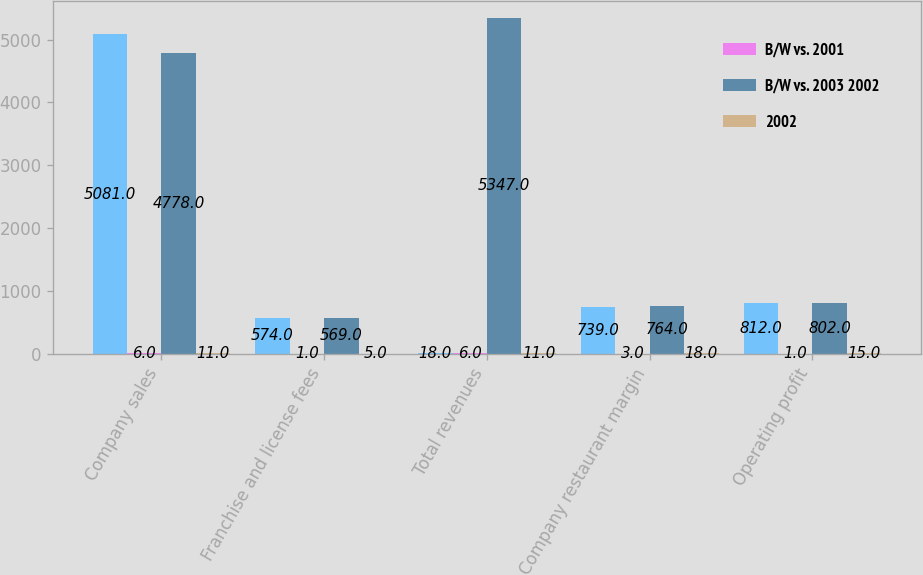<chart> <loc_0><loc_0><loc_500><loc_500><stacked_bar_chart><ecel><fcel>Company sales<fcel>Franchise and license fees<fcel>Total revenues<fcel>Company restaurant margin<fcel>Operating profit<nl><fcel>nan<fcel>5081<fcel>574<fcel>18<fcel>739<fcel>812<nl><fcel>B/W vs. 2001<fcel>6<fcel>1<fcel>6<fcel>3<fcel>1<nl><fcel>B/W vs. 2003 2002<fcel>4778<fcel>569<fcel>5347<fcel>764<fcel>802<nl><fcel>2002<fcel>11<fcel>5<fcel>11<fcel>18<fcel>15<nl></chart> 